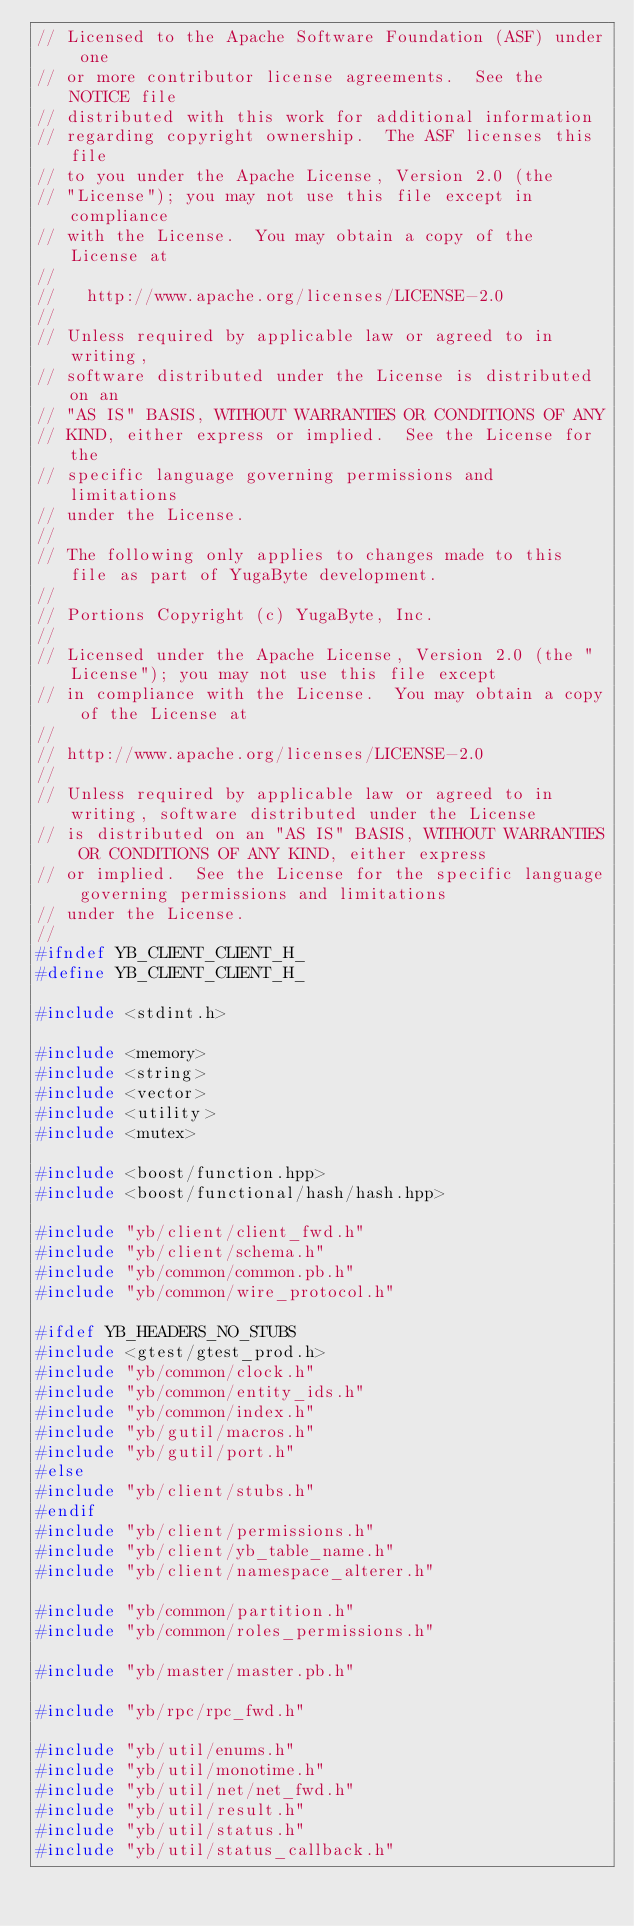<code> <loc_0><loc_0><loc_500><loc_500><_C_>// Licensed to the Apache Software Foundation (ASF) under one
// or more contributor license agreements.  See the NOTICE file
// distributed with this work for additional information
// regarding copyright ownership.  The ASF licenses this file
// to you under the Apache License, Version 2.0 (the
// "License"); you may not use this file except in compliance
// with the License.  You may obtain a copy of the License at
//
//   http://www.apache.org/licenses/LICENSE-2.0
//
// Unless required by applicable law or agreed to in writing,
// software distributed under the License is distributed on an
// "AS IS" BASIS, WITHOUT WARRANTIES OR CONDITIONS OF ANY
// KIND, either express or implied.  See the License for the
// specific language governing permissions and limitations
// under the License.
//
// The following only applies to changes made to this file as part of YugaByte development.
//
// Portions Copyright (c) YugaByte, Inc.
//
// Licensed under the Apache License, Version 2.0 (the "License"); you may not use this file except
// in compliance with the License.  You may obtain a copy of the License at
//
// http://www.apache.org/licenses/LICENSE-2.0
//
// Unless required by applicable law or agreed to in writing, software distributed under the License
// is distributed on an "AS IS" BASIS, WITHOUT WARRANTIES OR CONDITIONS OF ANY KIND, either express
// or implied.  See the License for the specific language governing permissions and limitations
// under the License.
//
#ifndef YB_CLIENT_CLIENT_H_
#define YB_CLIENT_CLIENT_H_

#include <stdint.h>

#include <memory>
#include <string>
#include <vector>
#include <utility>
#include <mutex>

#include <boost/function.hpp>
#include <boost/functional/hash/hash.hpp>

#include "yb/client/client_fwd.h"
#include "yb/client/schema.h"
#include "yb/common/common.pb.h"
#include "yb/common/wire_protocol.h"

#ifdef YB_HEADERS_NO_STUBS
#include <gtest/gtest_prod.h>
#include "yb/common/clock.h"
#include "yb/common/entity_ids.h"
#include "yb/common/index.h"
#include "yb/gutil/macros.h"
#include "yb/gutil/port.h"
#else
#include "yb/client/stubs.h"
#endif
#include "yb/client/permissions.h"
#include "yb/client/yb_table_name.h"
#include "yb/client/namespace_alterer.h"

#include "yb/common/partition.h"
#include "yb/common/roles_permissions.h"

#include "yb/master/master.pb.h"

#include "yb/rpc/rpc_fwd.h"

#include "yb/util/enums.h"
#include "yb/util/monotime.h"
#include "yb/util/net/net_fwd.h"
#include "yb/util/result.h"
#include "yb/util/status.h"
#include "yb/util/status_callback.h"</code> 